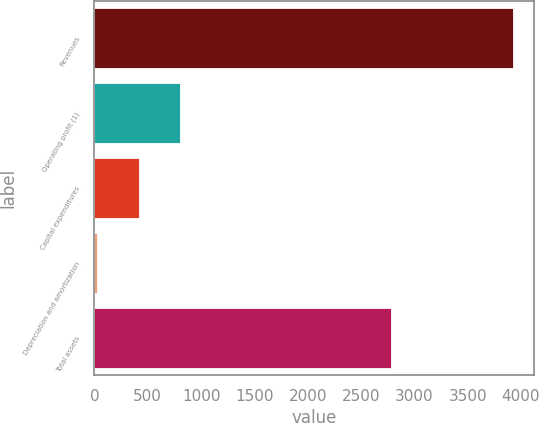Convert chart. <chart><loc_0><loc_0><loc_500><loc_500><bar_chart><fcel>Revenues<fcel>Operating profit (1)<fcel>Capital expenditures<fcel>Depreciation and amortization<fcel>Total assets<nl><fcel>3927<fcel>805.4<fcel>415.2<fcel>25<fcel>2784<nl></chart> 